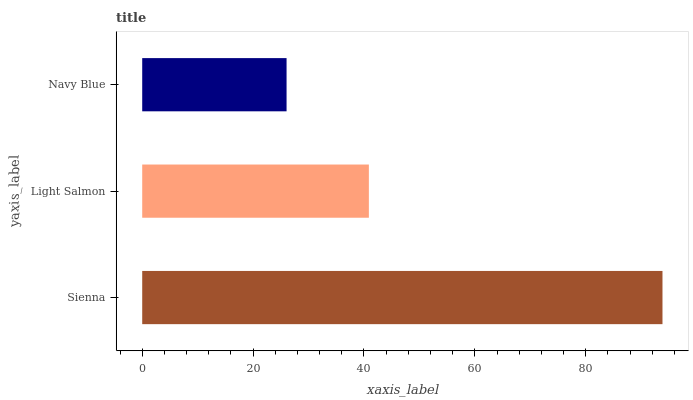Is Navy Blue the minimum?
Answer yes or no. Yes. Is Sienna the maximum?
Answer yes or no. Yes. Is Light Salmon the minimum?
Answer yes or no. No. Is Light Salmon the maximum?
Answer yes or no. No. Is Sienna greater than Light Salmon?
Answer yes or no. Yes. Is Light Salmon less than Sienna?
Answer yes or no. Yes. Is Light Salmon greater than Sienna?
Answer yes or no. No. Is Sienna less than Light Salmon?
Answer yes or no. No. Is Light Salmon the high median?
Answer yes or no. Yes. Is Light Salmon the low median?
Answer yes or no. Yes. Is Sienna the high median?
Answer yes or no. No. Is Navy Blue the low median?
Answer yes or no. No. 